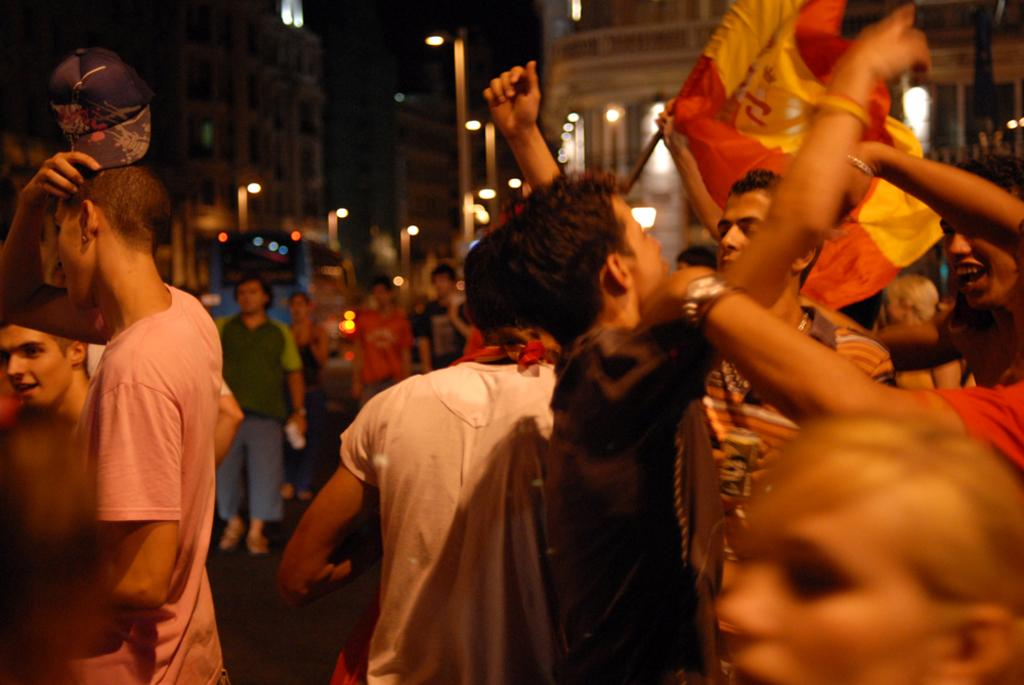What are the people in the image doing? The people in the image are standing on the road. What can be seen in the distance behind the people? There are buildings and street lights in the background of the image. Where is the bottle of water located in the image? There is no bottle of water present in the image. Is there a prison visible in the image? No, there is no prison visible in the image. 